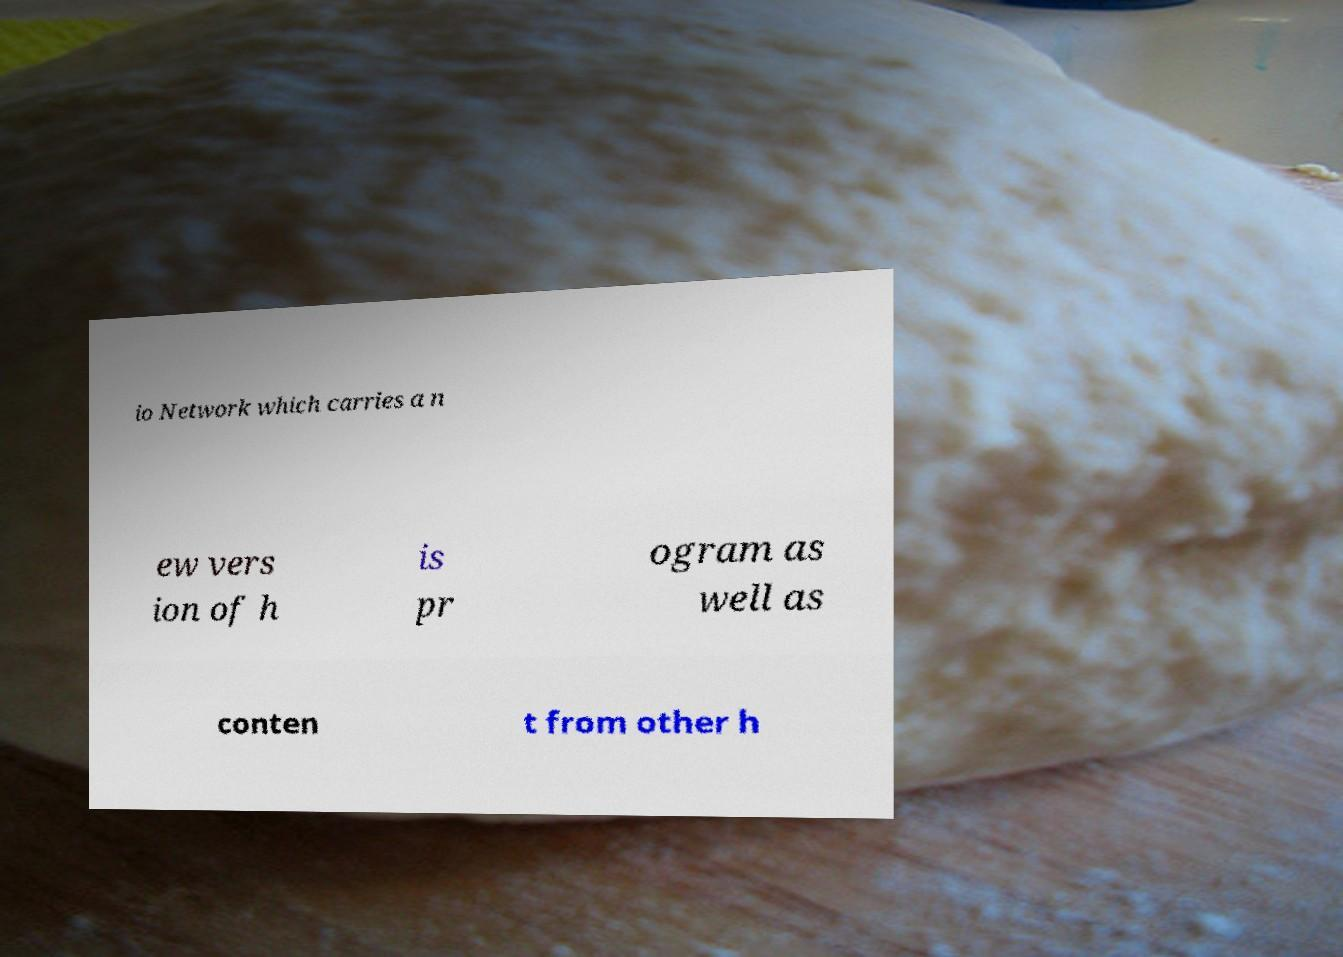For documentation purposes, I need the text within this image transcribed. Could you provide that? io Network which carries a n ew vers ion of h is pr ogram as well as conten t from other h 